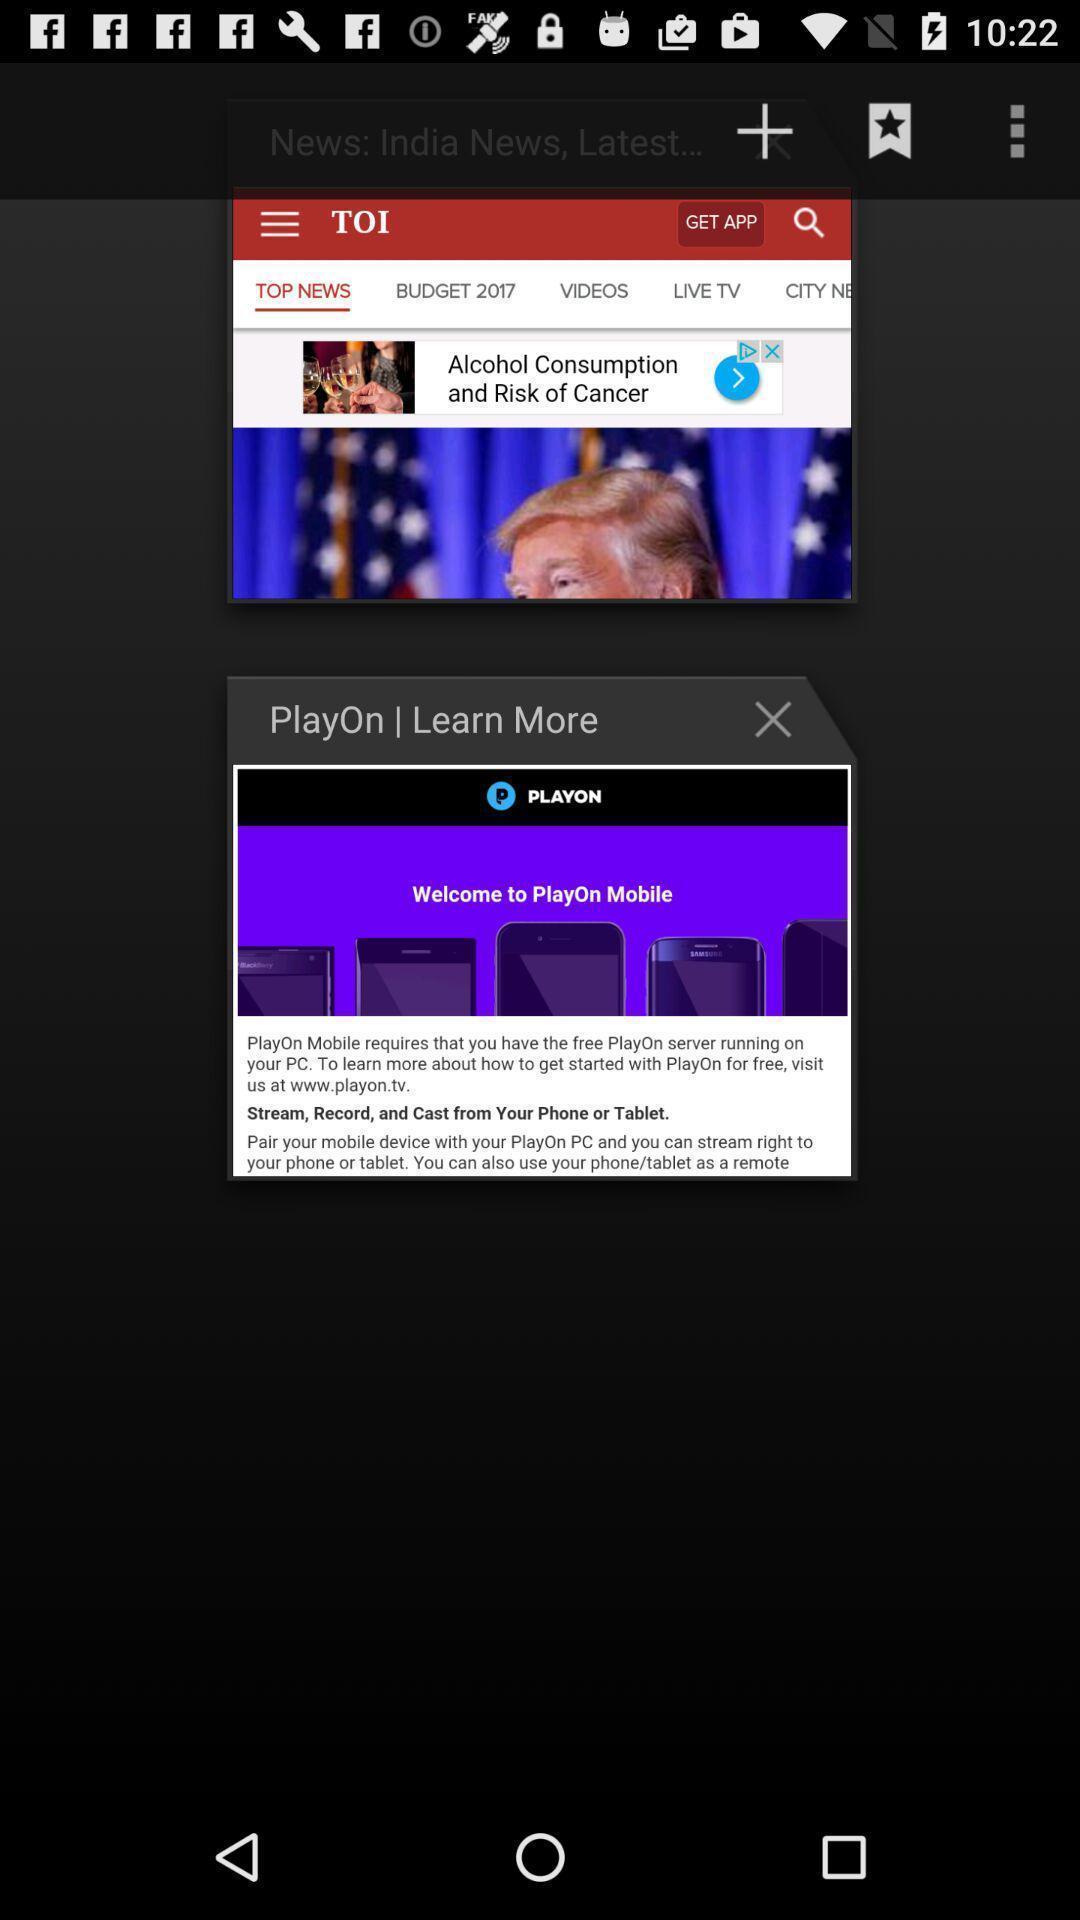Describe this image in words. Screen shows recent tabs page in browsing application. 